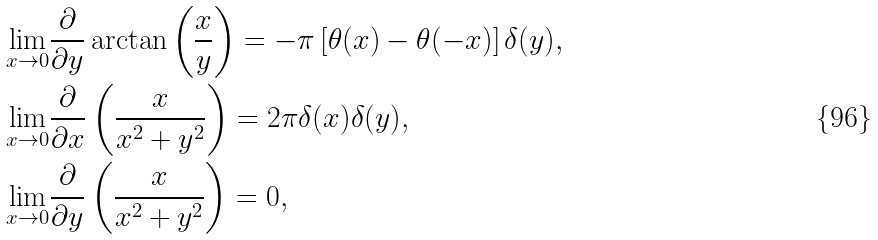Convert formula to latex. <formula><loc_0><loc_0><loc_500><loc_500>& \underset { x \to 0 } { \lim } \frac { \partial } { \partial y } \arctan \left ( \frac { x } { y } \right ) = - \pi \left [ \theta ( x ) - \theta ( - x ) \right ] \delta ( y ) , \\ & \underset { x \to 0 } { \lim } \frac { \partial } { \partial x } \left ( \frac { x } { x ^ { 2 } + y ^ { 2 } } \right ) = 2 \pi \delta ( x ) \delta ( y ) , \\ & \underset { x \to 0 } { \lim } \frac { \partial } { \partial y } \left ( \frac { x } { x ^ { 2 } + y ^ { 2 } } \right ) = 0 ,</formula> 